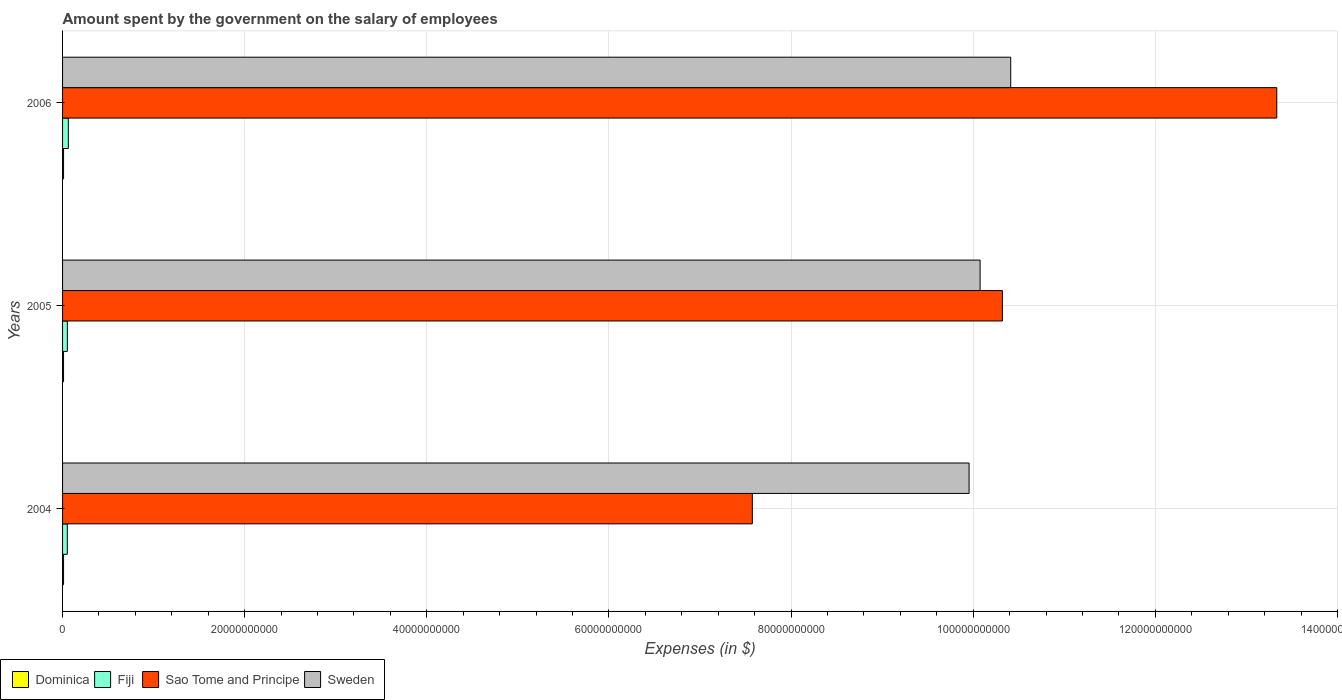How many bars are there on the 2nd tick from the top?
Ensure brevity in your answer.  4. How many bars are there on the 2nd tick from the bottom?
Your answer should be compact. 4. What is the label of the 2nd group of bars from the top?
Your answer should be compact. 2005. What is the amount spent on the salary of employees by the government in Sao Tome and Principe in 2004?
Offer a terse response. 7.57e+1. Across all years, what is the maximum amount spent on the salary of employees by the government in Fiji?
Provide a short and direct response. 6.32e+08. Across all years, what is the minimum amount spent on the salary of employees by the government in Dominica?
Offer a terse response. 1.08e+08. In which year was the amount spent on the salary of employees by the government in Dominica minimum?
Offer a terse response. 2005. What is the total amount spent on the salary of employees by the government in Fiji in the graph?
Make the answer very short. 1.68e+09. What is the difference between the amount spent on the salary of employees by the government in Fiji in 2004 and that in 2005?
Give a very brief answer. -6.00e+06. What is the difference between the amount spent on the salary of employees by the government in Fiji in 2004 and the amount spent on the salary of employees by the government in Dominica in 2006?
Offer a very short reply. 4.10e+08. What is the average amount spent on the salary of employees by the government in Fiji per year?
Provide a short and direct response. 5.59e+08. In the year 2006, what is the difference between the amount spent on the salary of employees by the government in Sweden and amount spent on the salary of employees by the government in Sao Tome and Principe?
Offer a very short reply. -2.92e+1. In how many years, is the amount spent on the salary of employees by the government in Dominica greater than 104000000000 $?
Your answer should be very brief. 0. What is the ratio of the amount spent on the salary of employees by the government in Fiji in 2004 to that in 2005?
Provide a succinct answer. 0.99. Is the amount spent on the salary of employees by the government in Dominica in 2005 less than that in 2006?
Your answer should be compact. Yes. What is the difference between the highest and the second highest amount spent on the salary of employees by the government in Fiji?
Keep it short and to the point. 1.07e+08. What is the difference between the highest and the lowest amount spent on the salary of employees by the government in Sweden?
Provide a succinct answer. 4.57e+09. Is the sum of the amount spent on the salary of employees by the government in Sao Tome and Principe in 2005 and 2006 greater than the maximum amount spent on the salary of employees by the government in Dominica across all years?
Ensure brevity in your answer.  Yes. What does the 4th bar from the top in 2005 represents?
Keep it short and to the point. Dominica. What does the 1st bar from the bottom in 2004 represents?
Offer a terse response. Dominica. How many bars are there?
Provide a succinct answer. 12. How many years are there in the graph?
Ensure brevity in your answer.  3. Are the values on the major ticks of X-axis written in scientific E-notation?
Give a very brief answer. No. What is the title of the graph?
Your answer should be compact. Amount spent by the government on the salary of employees. Does "Japan" appear as one of the legend labels in the graph?
Make the answer very short. No. What is the label or title of the X-axis?
Your answer should be very brief. Expenses (in $). What is the Expenses (in $) of Dominica in 2004?
Give a very brief answer. 1.09e+08. What is the Expenses (in $) of Fiji in 2004?
Provide a short and direct response. 5.19e+08. What is the Expenses (in $) of Sao Tome and Principe in 2004?
Offer a terse response. 7.57e+1. What is the Expenses (in $) of Sweden in 2004?
Your response must be concise. 9.95e+1. What is the Expenses (in $) of Dominica in 2005?
Make the answer very short. 1.08e+08. What is the Expenses (in $) of Fiji in 2005?
Give a very brief answer. 5.25e+08. What is the Expenses (in $) of Sao Tome and Principe in 2005?
Your response must be concise. 1.03e+11. What is the Expenses (in $) of Sweden in 2005?
Provide a short and direct response. 1.01e+11. What is the Expenses (in $) in Dominica in 2006?
Provide a succinct answer. 1.10e+08. What is the Expenses (in $) in Fiji in 2006?
Provide a succinct answer. 6.32e+08. What is the Expenses (in $) in Sao Tome and Principe in 2006?
Give a very brief answer. 1.33e+11. What is the Expenses (in $) in Sweden in 2006?
Give a very brief answer. 1.04e+11. Across all years, what is the maximum Expenses (in $) in Dominica?
Ensure brevity in your answer.  1.10e+08. Across all years, what is the maximum Expenses (in $) in Fiji?
Your response must be concise. 6.32e+08. Across all years, what is the maximum Expenses (in $) in Sao Tome and Principe?
Provide a succinct answer. 1.33e+11. Across all years, what is the maximum Expenses (in $) of Sweden?
Provide a short and direct response. 1.04e+11. Across all years, what is the minimum Expenses (in $) of Dominica?
Offer a terse response. 1.08e+08. Across all years, what is the minimum Expenses (in $) in Fiji?
Give a very brief answer. 5.19e+08. Across all years, what is the minimum Expenses (in $) in Sao Tome and Principe?
Offer a terse response. 7.57e+1. Across all years, what is the minimum Expenses (in $) in Sweden?
Offer a terse response. 9.95e+1. What is the total Expenses (in $) in Dominica in the graph?
Provide a short and direct response. 3.27e+08. What is the total Expenses (in $) in Fiji in the graph?
Offer a terse response. 1.68e+09. What is the total Expenses (in $) of Sao Tome and Principe in the graph?
Provide a short and direct response. 3.12e+11. What is the total Expenses (in $) of Sweden in the graph?
Ensure brevity in your answer.  3.04e+11. What is the difference between the Expenses (in $) in Fiji in 2004 and that in 2005?
Offer a very short reply. -6.00e+06. What is the difference between the Expenses (in $) of Sao Tome and Principe in 2004 and that in 2005?
Keep it short and to the point. -2.75e+1. What is the difference between the Expenses (in $) in Sweden in 2004 and that in 2005?
Your response must be concise. -1.21e+09. What is the difference between the Expenses (in $) in Dominica in 2004 and that in 2006?
Your response must be concise. -3.00e+05. What is the difference between the Expenses (in $) of Fiji in 2004 and that in 2006?
Keep it short and to the point. -1.13e+08. What is the difference between the Expenses (in $) of Sao Tome and Principe in 2004 and that in 2006?
Your answer should be compact. -5.76e+1. What is the difference between the Expenses (in $) of Sweden in 2004 and that in 2006?
Keep it short and to the point. -4.57e+09. What is the difference between the Expenses (in $) of Dominica in 2005 and that in 2006?
Your answer should be very brief. -1.10e+06. What is the difference between the Expenses (in $) in Fiji in 2005 and that in 2006?
Make the answer very short. -1.07e+08. What is the difference between the Expenses (in $) in Sao Tome and Principe in 2005 and that in 2006?
Give a very brief answer. -3.01e+1. What is the difference between the Expenses (in $) of Sweden in 2005 and that in 2006?
Ensure brevity in your answer.  -3.36e+09. What is the difference between the Expenses (in $) in Dominica in 2004 and the Expenses (in $) in Fiji in 2005?
Make the answer very short. -4.16e+08. What is the difference between the Expenses (in $) in Dominica in 2004 and the Expenses (in $) in Sao Tome and Principe in 2005?
Offer a terse response. -1.03e+11. What is the difference between the Expenses (in $) in Dominica in 2004 and the Expenses (in $) in Sweden in 2005?
Your answer should be compact. -1.01e+11. What is the difference between the Expenses (in $) of Fiji in 2004 and the Expenses (in $) of Sao Tome and Principe in 2005?
Offer a terse response. -1.03e+11. What is the difference between the Expenses (in $) of Fiji in 2004 and the Expenses (in $) of Sweden in 2005?
Provide a short and direct response. -1.00e+11. What is the difference between the Expenses (in $) of Sao Tome and Principe in 2004 and the Expenses (in $) of Sweden in 2005?
Give a very brief answer. -2.50e+1. What is the difference between the Expenses (in $) in Dominica in 2004 and the Expenses (in $) in Fiji in 2006?
Offer a terse response. -5.23e+08. What is the difference between the Expenses (in $) of Dominica in 2004 and the Expenses (in $) of Sao Tome and Principe in 2006?
Offer a very short reply. -1.33e+11. What is the difference between the Expenses (in $) in Dominica in 2004 and the Expenses (in $) in Sweden in 2006?
Provide a short and direct response. -1.04e+11. What is the difference between the Expenses (in $) in Fiji in 2004 and the Expenses (in $) in Sao Tome and Principe in 2006?
Offer a very short reply. -1.33e+11. What is the difference between the Expenses (in $) in Fiji in 2004 and the Expenses (in $) in Sweden in 2006?
Your answer should be very brief. -1.04e+11. What is the difference between the Expenses (in $) of Sao Tome and Principe in 2004 and the Expenses (in $) of Sweden in 2006?
Give a very brief answer. -2.84e+1. What is the difference between the Expenses (in $) of Dominica in 2005 and the Expenses (in $) of Fiji in 2006?
Provide a short and direct response. -5.24e+08. What is the difference between the Expenses (in $) of Dominica in 2005 and the Expenses (in $) of Sao Tome and Principe in 2006?
Your response must be concise. -1.33e+11. What is the difference between the Expenses (in $) of Dominica in 2005 and the Expenses (in $) of Sweden in 2006?
Your answer should be compact. -1.04e+11. What is the difference between the Expenses (in $) in Fiji in 2005 and the Expenses (in $) in Sao Tome and Principe in 2006?
Your answer should be compact. -1.33e+11. What is the difference between the Expenses (in $) in Fiji in 2005 and the Expenses (in $) in Sweden in 2006?
Keep it short and to the point. -1.04e+11. What is the difference between the Expenses (in $) in Sao Tome and Principe in 2005 and the Expenses (in $) in Sweden in 2006?
Provide a short and direct response. -9.14e+08. What is the average Expenses (in $) of Dominica per year?
Provide a short and direct response. 1.09e+08. What is the average Expenses (in $) in Fiji per year?
Ensure brevity in your answer.  5.59e+08. What is the average Expenses (in $) of Sao Tome and Principe per year?
Ensure brevity in your answer.  1.04e+11. What is the average Expenses (in $) of Sweden per year?
Provide a short and direct response. 1.01e+11. In the year 2004, what is the difference between the Expenses (in $) of Dominica and Expenses (in $) of Fiji?
Your answer should be compact. -4.10e+08. In the year 2004, what is the difference between the Expenses (in $) in Dominica and Expenses (in $) in Sao Tome and Principe?
Keep it short and to the point. -7.56e+1. In the year 2004, what is the difference between the Expenses (in $) of Dominica and Expenses (in $) of Sweden?
Keep it short and to the point. -9.94e+1. In the year 2004, what is the difference between the Expenses (in $) of Fiji and Expenses (in $) of Sao Tome and Principe?
Provide a short and direct response. -7.52e+1. In the year 2004, what is the difference between the Expenses (in $) of Fiji and Expenses (in $) of Sweden?
Offer a terse response. -9.90e+1. In the year 2004, what is the difference between the Expenses (in $) in Sao Tome and Principe and Expenses (in $) in Sweden?
Your response must be concise. -2.38e+1. In the year 2005, what is the difference between the Expenses (in $) of Dominica and Expenses (in $) of Fiji?
Keep it short and to the point. -4.17e+08. In the year 2005, what is the difference between the Expenses (in $) of Dominica and Expenses (in $) of Sao Tome and Principe?
Provide a succinct answer. -1.03e+11. In the year 2005, what is the difference between the Expenses (in $) in Dominica and Expenses (in $) in Sweden?
Your response must be concise. -1.01e+11. In the year 2005, what is the difference between the Expenses (in $) of Fiji and Expenses (in $) of Sao Tome and Principe?
Offer a terse response. -1.03e+11. In the year 2005, what is the difference between the Expenses (in $) of Fiji and Expenses (in $) of Sweden?
Keep it short and to the point. -1.00e+11. In the year 2005, what is the difference between the Expenses (in $) in Sao Tome and Principe and Expenses (in $) in Sweden?
Your response must be concise. 2.45e+09. In the year 2006, what is the difference between the Expenses (in $) in Dominica and Expenses (in $) in Fiji?
Offer a very short reply. -5.23e+08. In the year 2006, what is the difference between the Expenses (in $) of Dominica and Expenses (in $) of Sao Tome and Principe?
Offer a very short reply. -1.33e+11. In the year 2006, what is the difference between the Expenses (in $) in Dominica and Expenses (in $) in Sweden?
Your response must be concise. -1.04e+11. In the year 2006, what is the difference between the Expenses (in $) of Fiji and Expenses (in $) of Sao Tome and Principe?
Your response must be concise. -1.33e+11. In the year 2006, what is the difference between the Expenses (in $) in Fiji and Expenses (in $) in Sweden?
Make the answer very short. -1.03e+11. In the year 2006, what is the difference between the Expenses (in $) of Sao Tome and Principe and Expenses (in $) of Sweden?
Give a very brief answer. 2.92e+1. What is the ratio of the Expenses (in $) in Dominica in 2004 to that in 2005?
Give a very brief answer. 1.01. What is the ratio of the Expenses (in $) in Sao Tome and Principe in 2004 to that in 2005?
Your answer should be very brief. 0.73. What is the ratio of the Expenses (in $) of Sweden in 2004 to that in 2005?
Ensure brevity in your answer.  0.99. What is the ratio of the Expenses (in $) in Fiji in 2004 to that in 2006?
Your answer should be compact. 0.82. What is the ratio of the Expenses (in $) in Sao Tome and Principe in 2004 to that in 2006?
Offer a terse response. 0.57. What is the ratio of the Expenses (in $) of Sweden in 2004 to that in 2006?
Give a very brief answer. 0.96. What is the ratio of the Expenses (in $) in Fiji in 2005 to that in 2006?
Offer a terse response. 0.83. What is the ratio of the Expenses (in $) of Sao Tome and Principe in 2005 to that in 2006?
Your response must be concise. 0.77. What is the ratio of the Expenses (in $) in Sweden in 2005 to that in 2006?
Make the answer very short. 0.97. What is the difference between the highest and the second highest Expenses (in $) of Dominica?
Offer a very short reply. 3.00e+05. What is the difference between the highest and the second highest Expenses (in $) of Fiji?
Offer a very short reply. 1.07e+08. What is the difference between the highest and the second highest Expenses (in $) of Sao Tome and Principe?
Offer a terse response. 3.01e+1. What is the difference between the highest and the second highest Expenses (in $) in Sweden?
Your response must be concise. 3.36e+09. What is the difference between the highest and the lowest Expenses (in $) of Dominica?
Give a very brief answer. 1.10e+06. What is the difference between the highest and the lowest Expenses (in $) of Fiji?
Provide a succinct answer. 1.13e+08. What is the difference between the highest and the lowest Expenses (in $) in Sao Tome and Principe?
Your answer should be very brief. 5.76e+1. What is the difference between the highest and the lowest Expenses (in $) of Sweden?
Offer a very short reply. 4.57e+09. 